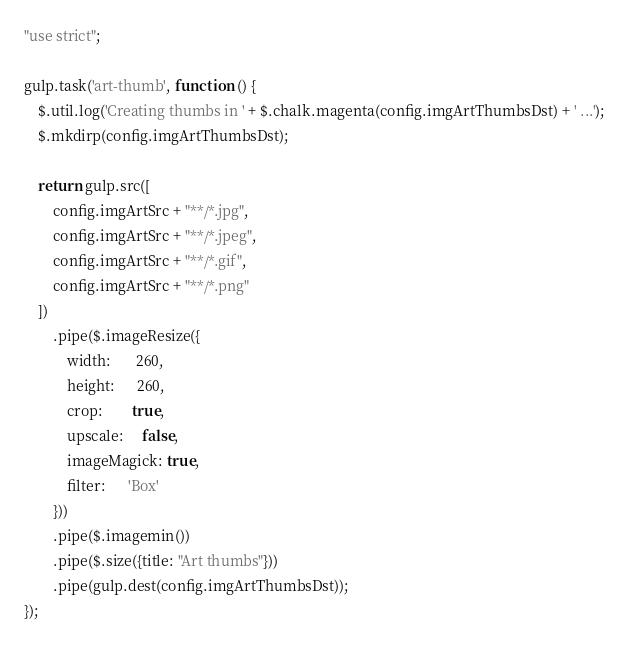<code> <loc_0><loc_0><loc_500><loc_500><_JavaScript_>"use strict";

gulp.task('art-thumb', function () {
    $.util.log('Creating thumbs in ' + $.chalk.magenta(config.imgArtThumbsDst) + ' ...');
    $.mkdirp(config.imgArtThumbsDst);

    return gulp.src([
        config.imgArtSrc + "**/*.jpg",
        config.imgArtSrc + "**/*.jpeg",
        config.imgArtSrc + "**/*.gif",
        config.imgArtSrc + "**/*.png"
    ])
        .pipe($.imageResize({
            width:       260,
            height:      260,
            crop:        true,
            upscale:     false,
            imageMagick: true,
            filter:      'Box'
        }))
        .pipe($.imagemin())
        .pipe($.size({title: "Art thumbs"}))
        .pipe(gulp.dest(config.imgArtThumbsDst));
});</code> 